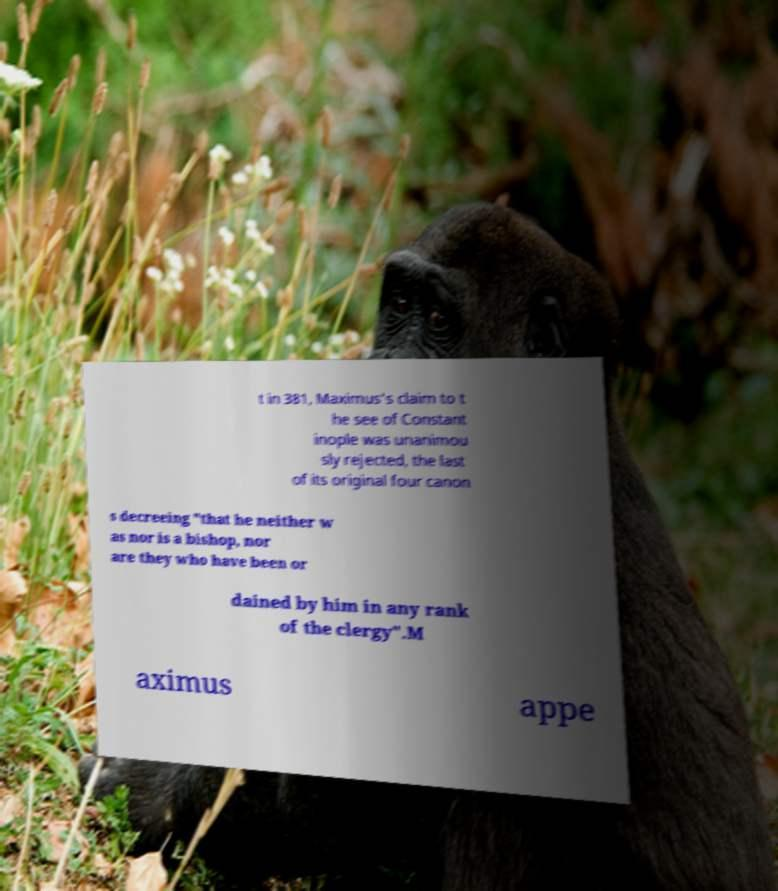Can you accurately transcribe the text from the provided image for me? t in 381, Maximus's claim to t he see of Constant inople was unanimou sly rejected, the last of its original four canon s decreeing "that he neither w as nor is a bishop, nor are they who have been or dained by him in any rank of the clergy".M aximus appe 